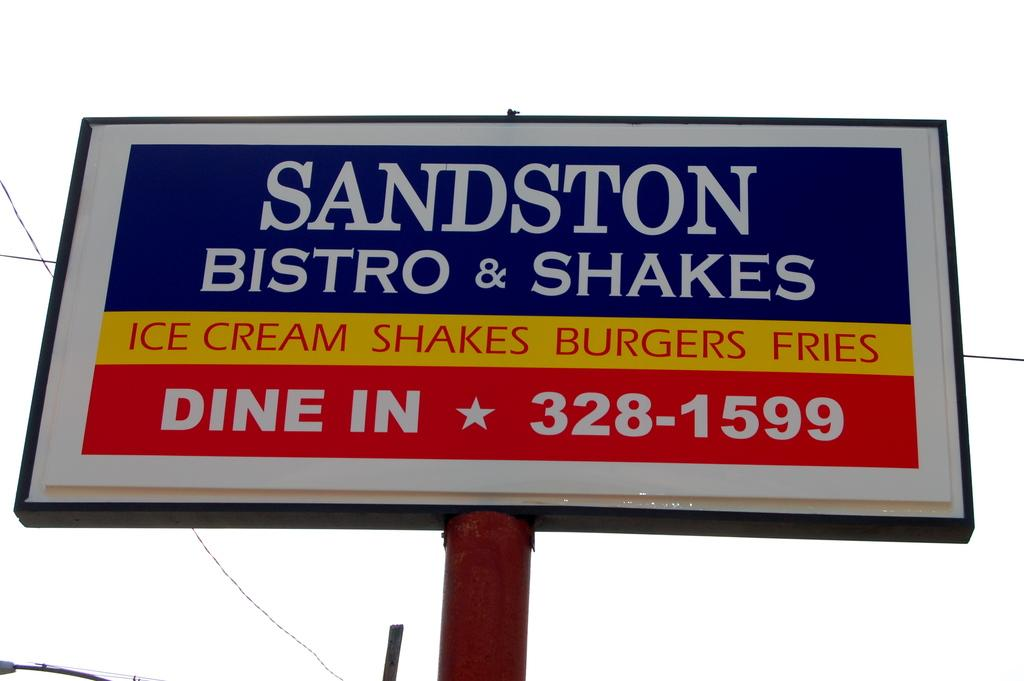<image>
Summarize the visual content of the image. A billboard advertising Sandston Bistro & Shakes Dine In. 